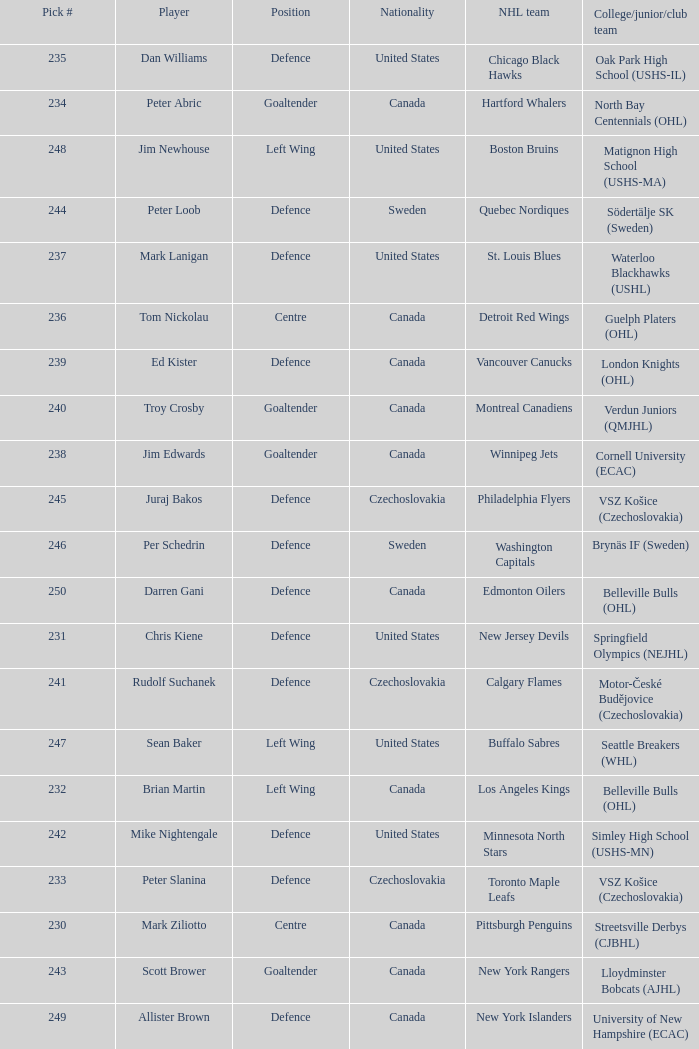What selection was the springfield olympics (nejhl)? 231.0. Write the full table. {'header': ['Pick #', 'Player', 'Position', 'Nationality', 'NHL team', 'College/junior/club team'], 'rows': [['235', 'Dan Williams', 'Defence', 'United States', 'Chicago Black Hawks', 'Oak Park High School (USHS-IL)'], ['234', 'Peter Abric', 'Goaltender', 'Canada', 'Hartford Whalers', 'North Bay Centennials (OHL)'], ['248', 'Jim Newhouse', 'Left Wing', 'United States', 'Boston Bruins', 'Matignon High School (USHS-MA)'], ['244', 'Peter Loob', 'Defence', 'Sweden', 'Quebec Nordiques', 'Södertälje SK (Sweden)'], ['237', 'Mark Lanigan', 'Defence', 'United States', 'St. Louis Blues', 'Waterloo Blackhawks (USHL)'], ['236', 'Tom Nickolau', 'Centre', 'Canada', 'Detroit Red Wings', 'Guelph Platers (OHL)'], ['239', 'Ed Kister', 'Defence', 'Canada', 'Vancouver Canucks', 'London Knights (OHL)'], ['240', 'Troy Crosby', 'Goaltender', 'Canada', 'Montreal Canadiens', 'Verdun Juniors (QMJHL)'], ['238', 'Jim Edwards', 'Goaltender', 'Canada', 'Winnipeg Jets', 'Cornell University (ECAC)'], ['245', 'Juraj Bakos', 'Defence', 'Czechoslovakia', 'Philadelphia Flyers', 'VSZ Košice (Czechoslovakia)'], ['246', 'Per Schedrin', 'Defence', 'Sweden', 'Washington Capitals', 'Brynäs IF (Sweden)'], ['250', 'Darren Gani', 'Defence', 'Canada', 'Edmonton Oilers', 'Belleville Bulls (OHL)'], ['231', 'Chris Kiene', 'Defence', 'United States', 'New Jersey Devils', 'Springfield Olympics (NEJHL)'], ['241', 'Rudolf Suchanek', 'Defence', 'Czechoslovakia', 'Calgary Flames', 'Motor-České Budějovice (Czechoslovakia)'], ['247', 'Sean Baker', 'Left Wing', 'United States', 'Buffalo Sabres', 'Seattle Breakers (WHL)'], ['232', 'Brian Martin', 'Left Wing', 'Canada', 'Los Angeles Kings', 'Belleville Bulls (OHL)'], ['242', 'Mike Nightengale', 'Defence', 'United States', 'Minnesota North Stars', 'Simley High School (USHS-MN)'], ['233', 'Peter Slanina', 'Defence', 'Czechoslovakia', 'Toronto Maple Leafs', 'VSZ Košice (Czechoslovakia)'], ['230', 'Mark Ziliotto', 'Centre', 'Canada', 'Pittsburgh Penguins', 'Streetsville Derbys (CJBHL)'], ['243', 'Scott Brower', 'Goaltender', 'Canada', 'New York Rangers', 'Lloydminster Bobcats (AJHL)'], ['249', 'Allister Brown', 'Defence', 'Canada', 'New York Islanders', 'University of New Hampshire (ECAC)']]} 